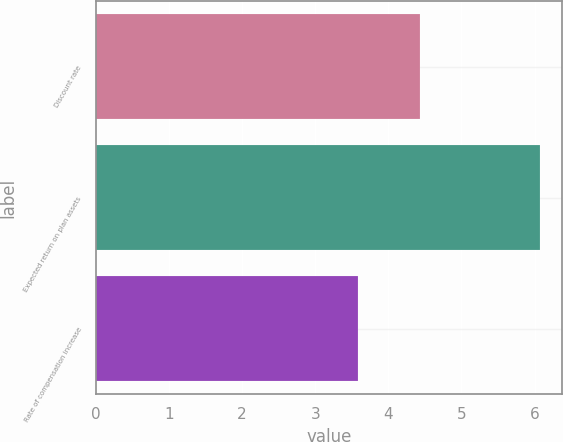Convert chart. <chart><loc_0><loc_0><loc_500><loc_500><bar_chart><fcel>Discount rate<fcel>Expected return on plan assets<fcel>Rate of compensation increase<nl><fcel>4.43<fcel>6.07<fcel>3.59<nl></chart> 